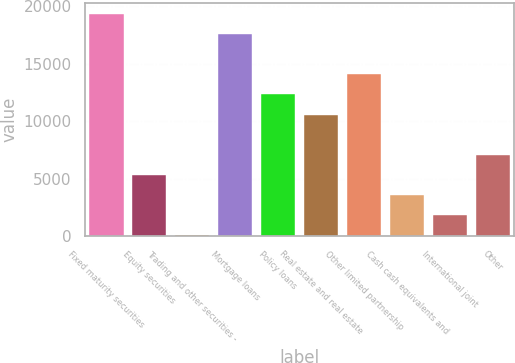Convert chart to OTSL. <chart><loc_0><loc_0><loc_500><loc_500><bar_chart><fcel>Fixed maturity securities<fcel>Equity securities<fcel>Trading and other securities -<fcel>Mortgage loans<fcel>Policy loans<fcel>Real estate and real estate<fcel>Other limited partnership<fcel>Cash cash equivalents and<fcel>International joint<fcel>Other<nl><fcel>19360.4<fcel>5333.2<fcel>73<fcel>17607<fcel>12346.8<fcel>10593.4<fcel>14100.2<fcel>3579.8<fcel>1826.4<fcel>7086.6<nl></chart> 